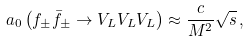Convert formula to latex. <formula><loc_0><loc_0><loc_500><loc_500>a _ { 0 } \left ( f _ { \pm } \bar { f } _ { \pm } \to V _ { L } V _ { L } V _ { L } \right ) \approx \frac { c } { M ^ { 2 } } \sqrt { s } \, ,</formula> 